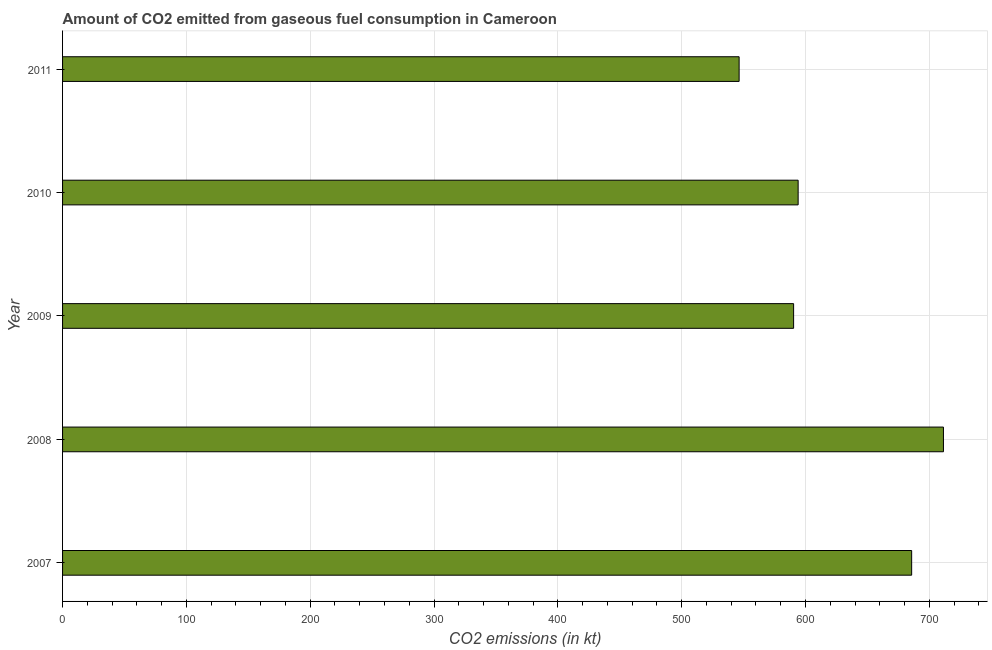Does the graph contain grids?
Your answer should be very brief. Yes. What is the title of the graph?
Ensure brevity in your answer.  Amount of CO2 emitted from gaseous fuel consumption in Cameroon. What is the label or title of the X-axis?
Your answer should be very brief. CO2 emissions (in kt). What is the co2 emissions from gaseous fuel consumption in 2011?
Give a very brief answer. 546.38. Across all years, what is the maximum co2 emissions from gaseous fuel consumption?
Give a very brief answer. 711.4. Across all years, what is the minimum co2 emissions from gaseous fuel consumption?
Offer a very short reply. 546.38. In which year was the co2 emissions from gaseous fuel consumption minimum?
Make the answer very short. 2011. What is the sum of the co2 emissions from gaseous fuel consumption?
Your answer should be very brief. 3127.95. What is the difference between the co2 emissions from gaseous fuel consumption in 2007 and 2010?
Keep it short and to the point. 91.67. What is the average co2 emissions from gaseous fuel consumption per year?
Your response must be concise. 625.59. What is the median co2 emissions from gaseous fuel consumption?
Give a very brief answer. 594.05. In how many years, is the co2 emissions from gaseous fuel consumption greater than 400 kt?
Make the answer very short. 5. What is the ratio of the co2 emissions from gaseous fuel consumption in 2009 to that in 2010?
Your answer should be compact. 0.99. Is the co2 emissions from gaseous fuel consumption in 2008 less than that in 2009?
Provide a succinct answer. No. What is the difference between the highest and the second highest co2 emissions from gaseous fuel consumption?
Your answer should be very brief. 25.67. What is the difference between the highest and the lowest co2 emissions from gaseous fuel consumption?
Your answer should be compact. 165.01. How many bars are there?
Provide a succinct answer. 5. Are all the bars in the graph horizontal?
Your answer should be compact. Yes. How many years are there in the graph?
Your answer should be compact. 5. What is the CO2 emissions (in kt) of 2007?
Offer a terse response. 685.73. What is the CO2 emissions (in kt) of 2008?
Keep it short and to the point. 711.4. What is the CO2 emissions (in kt) of 2009?
Ensure brevity in your answer.  590.39. What is the CO2 emissions (in kt) of 2010?
Provide a short and direct response. 594.05. What is the CO2 emissions (in kt) of 2011?
Provide a short and direct response. 546.38. What is the difference between the CO2 emissions (in kt) in 2007 and 2008?
Provide a short and direct response. -25.67. What is the difference between the CO2 emissions (in kt) in 2007 and 2009?
Offer a terse response. 95.34. What is the difference between the CO2 emissions (in kt) in 2007 and 2010?
Your answer should be compact. 91.67. What is the difference between the CO2 emissions (in kt) in 2007 and 2011?
Offer a terse response. 139.35. What is the difference between the CO2 emissions (in kt) in 2008 and 2009?
Provide a succinct answer. 121.01. What is the difference between the CO2 emissions (in kt) in 2008 and 2010?
Make the answer very short. 117.34. What is the difference between the CO2 emissions (in kt) in 2008 and 2011?
Ensure brevity in your answer.  165.01. What is the difference between the CO2 emissions (in kt) in 2009 and 2010?
Keep it short and to the point. -3.67. What is the difference between the CO2 emissions (in kt) in 2009 and 2011?
Provide a short and direct response. 44. What is the difference between the CO2 emissions (in kt) in 2010 and 2011?
Your answer should be compact. 47.67. What is the ratio of the CO2 emissions (in kt) in 2007 to that in 2009?
Give a very brief answer. 1.16. What is the ratio of the CO2 emissions (in kt) in 2007 to that in 2010?
Offer a very short reply. 1.15. What is the ratio of the CO2 emissions (in kt) in 2007 to that in 2011?
Ensure brevity in your answer.  1.25. What is the ratio of the CO2 emissions (in kt) in 2008 to that in 2009?
Keep it short and to the point. 1.21. What is the ratio of the CO2 emissions (in kt) in 2008 to that in 2010?
Give a very brief answer. 1.2. What is the ratio of the CO2 emissions (in kt) in 2008 to that in 2011?
Give a very brief answer. 1.3. What is the ratio of the CO2 emissions (in kt) in 2009 to that in 2011?
Offer a very short reply. 1.08. What is the ratio of the CO2 emissions (in kt) in 2010 to that in 2011?
Provide a short and direct response. 1.09. 